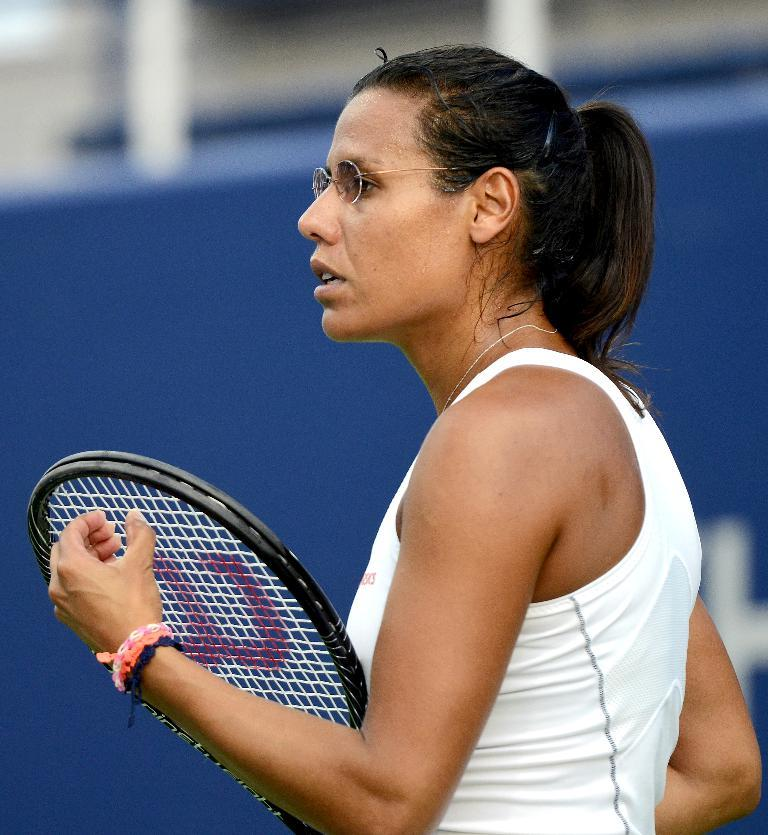Who is the main subject in the image? There is a woman in the image. What is the woman holding in the image? The woman is holding a tennis racket. What accessory is the woman wearing in the image? The woman is wearing spectacles. What color is the shirt the woman is wearing? The woman is wearing a white shirt. How is the background of the image depicted? The background of the woman is blurred. What type of band is playing in the background of the image? There is no band present in the image; it features a woman holding a tennis racket with a blurred background. How does the crow interact with the woman in the image? There is no crow present in the image; it only features a woman holding a tennis racket. 